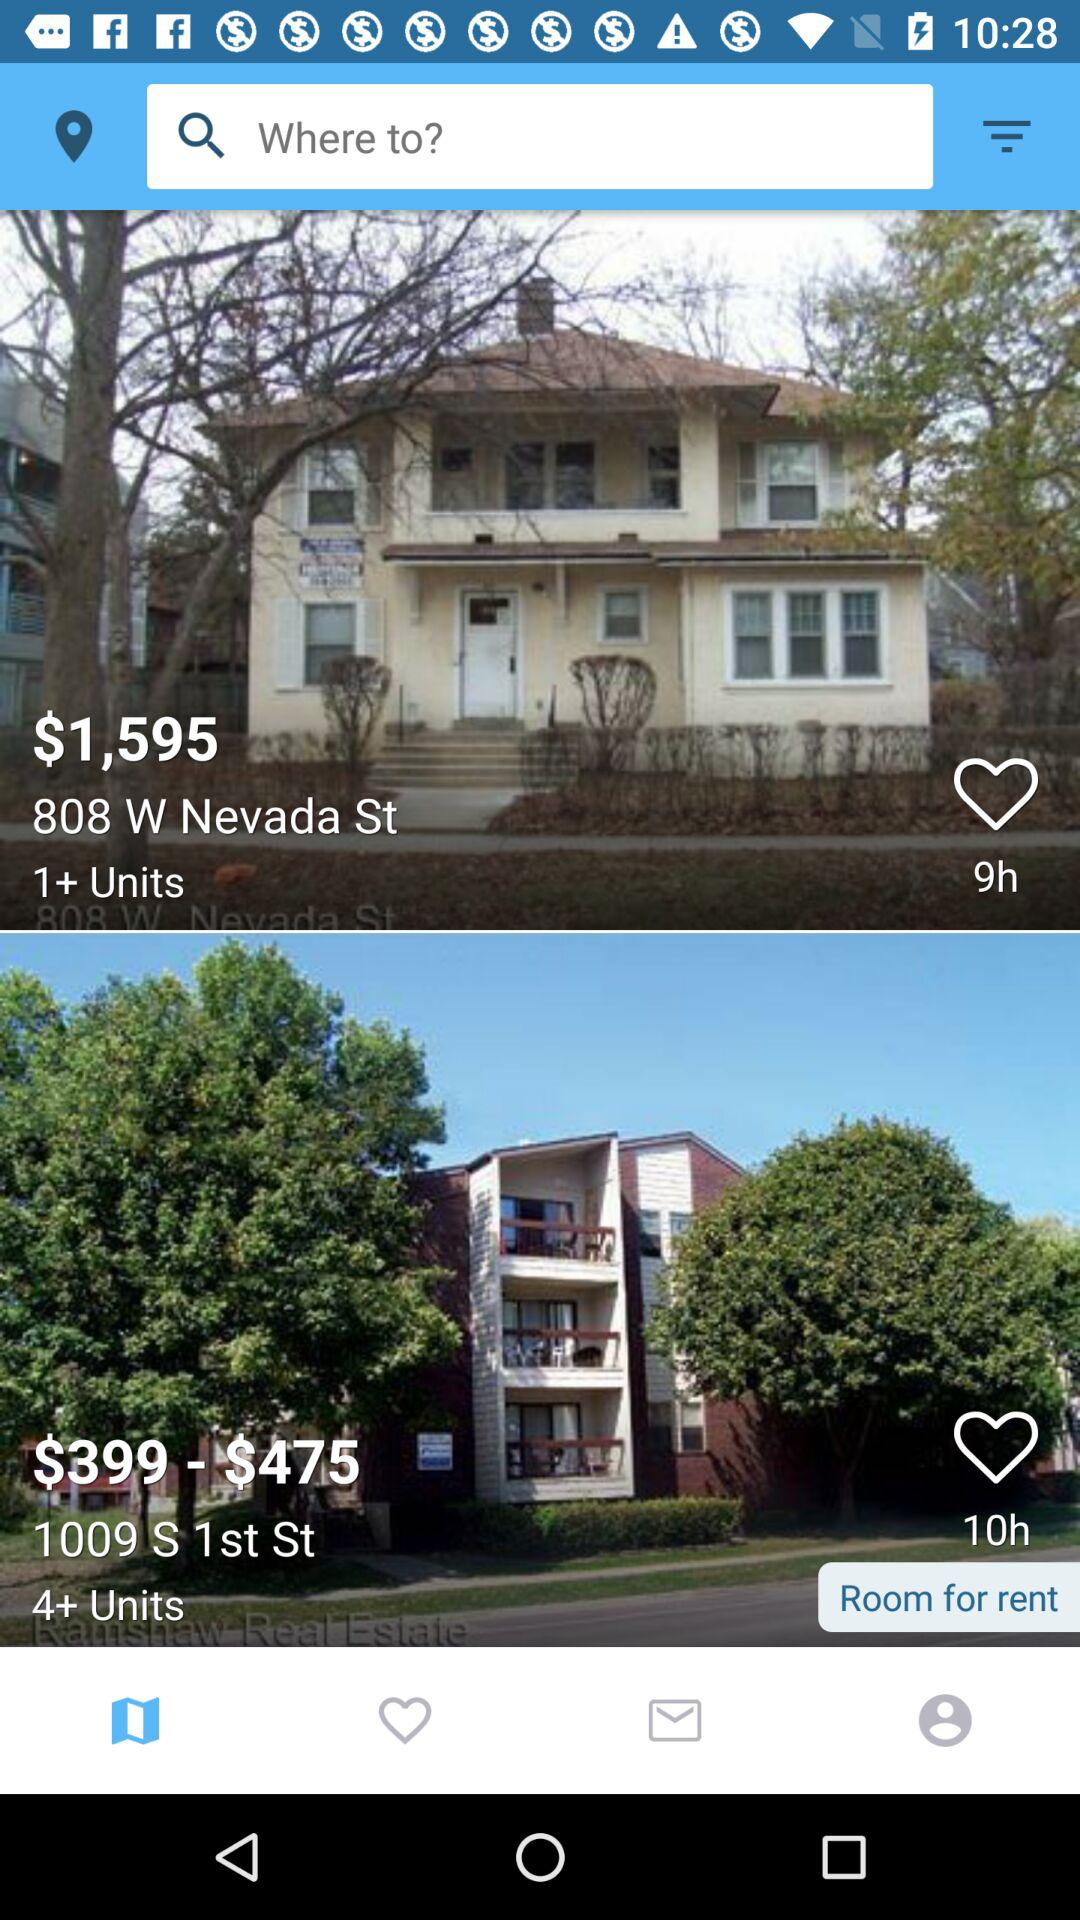How many more units are available on the house on 1009 S 1st St than the house on 808 W Nevada St?
Answer the question using a single word or phrase. 3 